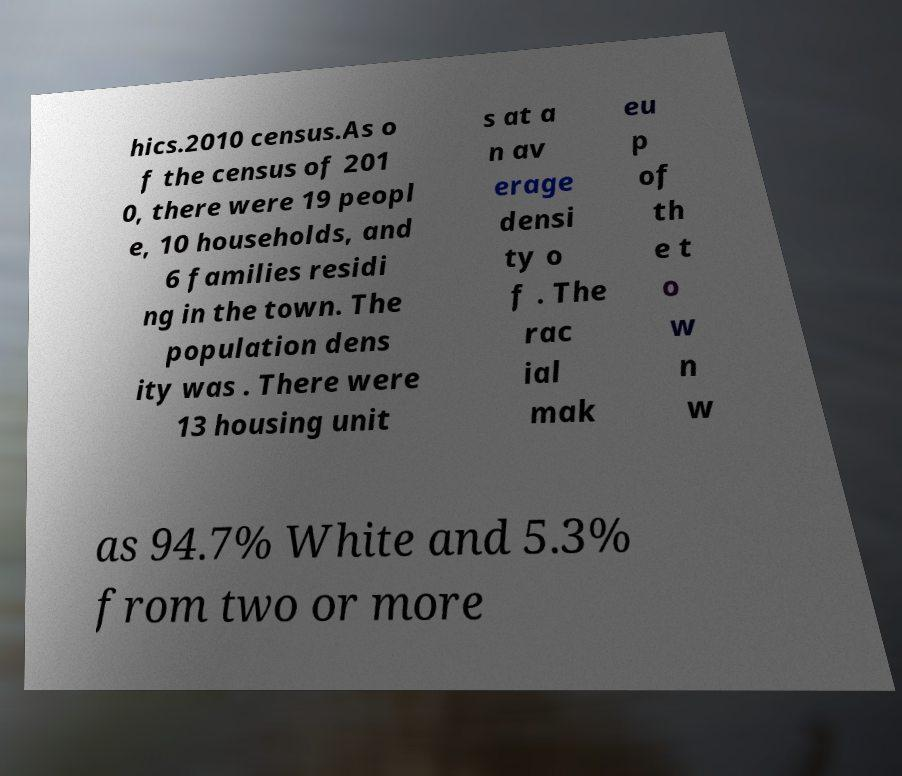Could you extract and type out the text from this image? hics.2010 census.As o f the census of 201 0, there were 19 peopl e, 10 households, and 6 families residi ng in the town. The population dens ity was . There were 13 housing unit s at a n av erage densi ty o f . The rac ial mak eu p of th e t o w n w as 94.7% White and 5.3% from two or more 